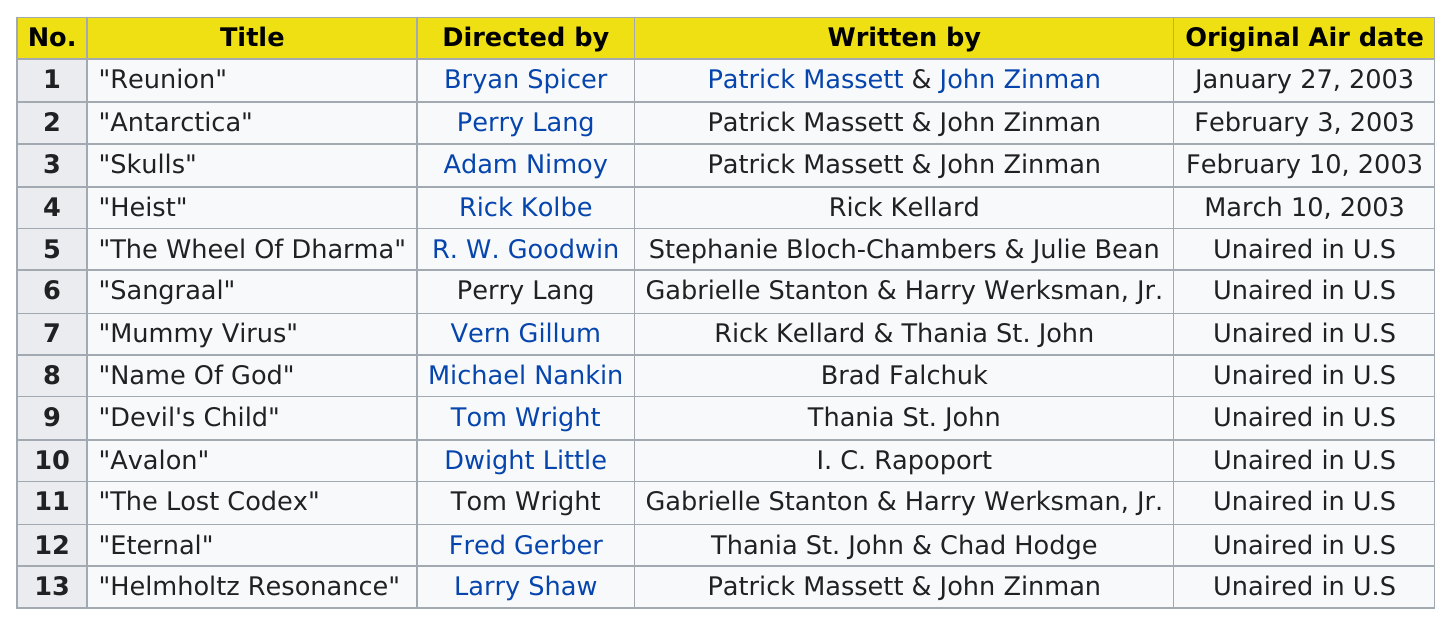Identify some key points in this picture. Ninety episodes of the show did not air in the United States. The number of items written by Brad Falchuk is 1.. Nine unaired episodes are present in the United States. The name of the first title listed in this chart is "Reunion. Episode #10 or #5 has a longer name, with #5 having a slightly longer name 